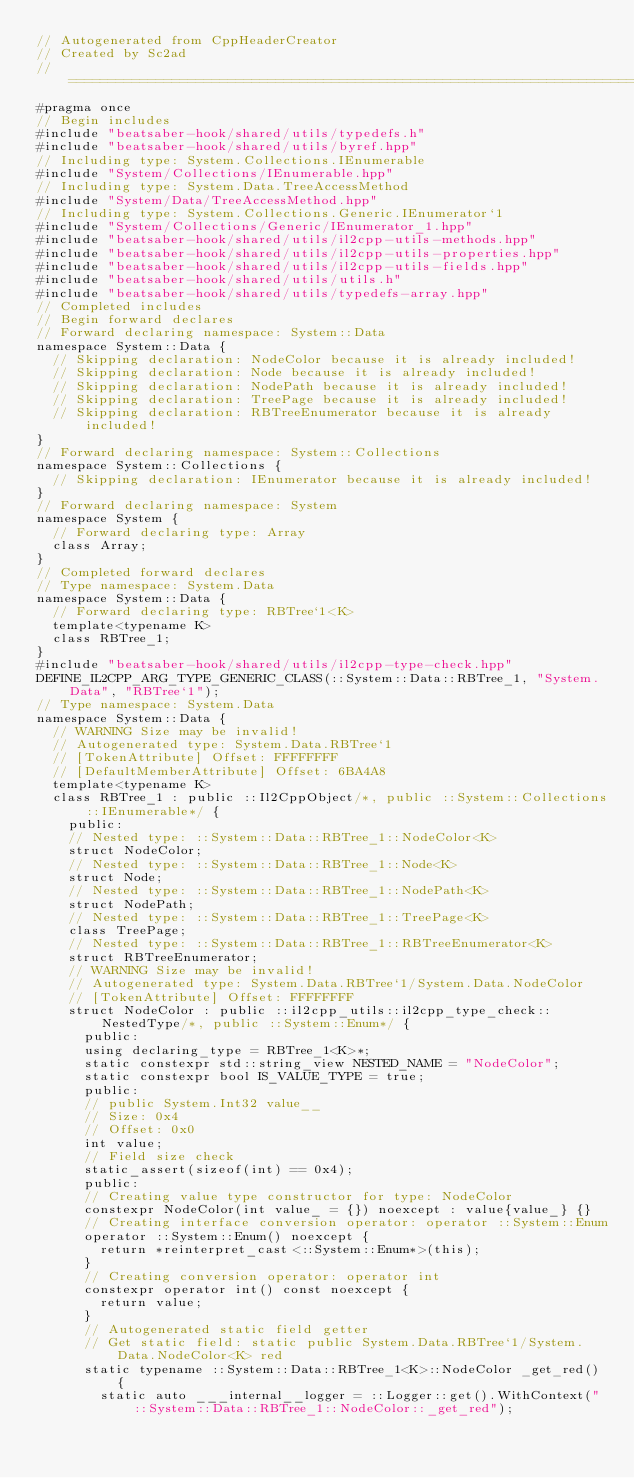Convert code to text. <code><loc_0><loc_0><loc_500><loc_500><_C++_>// Autogenerated from CppHeaderCreator
// Created by Sc2ad
// =========================================================================
#pragma once
// Begin includes
#include "beatsaber-hook/shared/utils/typedefs.h"
#include "beatsaber-hook/shared/utils/byref.hpp"
// Including type: System.Collections.IEnumerable
#include "System/Collections/IEnumerable.hpp"
// Including type: System.Data.TreeAccessMethod
#include "System/Data/TreeAccessMethod.hpp"
// Including type: System.Collections.Generic.IEnumerator`1
#include "System/Collections/Generic/IEnumerator_1.hpp"
#include "beatsaber-hook/shared/utils/il2cpp-utils-methods.hpp"
#include "beatsaber-hook/shared/utils/il2cpp-utils-properties.hpp"
#include "beatsaber-hook/shared/utils/il2cpp-utils-fields.hpp"
#include "beatsaber-hook/shared/utils/utils.h"
#include "beatsaber-hook/shared/utils/typedefs-array.hpp"
// Completed includes
// Begin forward declares
// Forward declaring namespace: System::Data
namespace System::Data {
  // Skipping declaration: NodeColor because it is already included!
  // Skipping declaration: Node because it is already included!
  // Skipping declaration: NodePath because it is already included!
  // Skipping declaration: TreePage because it is already included!
  // Skipping declaration: RBTreeEnumerator because it is already included!
}
// Forward declaring namespace: System::Collections
namespace System::Collections {
  // Skipping declaration: IEnumerator because it is already included!
}
// Forward declaring namespace: System
namespace System {
  // Forward declaring type: Array
  class Array;
}
// Completed forward declares
// Type namespace: System.Data
namespace System::Data {
  // Forward declaring type: RBTree`1<K>
  template<typename K>
  class RBTree_1;
}
#include "beatsaber-hook/shared/utils/il2cpp-type-check.hpp"
DEFINE_IL2CPP_ARG_TYPE_GENERIC_CLASS(::System::Data::RBTree_1, "System.Data", "RBTree`1");
// Type namespace: System.Data
namespace System::Data {
  // WARNING Size may be invalid!
  // Autogenerated type: System.Data.RBTree`1
  // [TokenAttribute] Offset: FFFFFFFF
  // [DefaultMemberAttribute] Offset: 6BA4A8
  template<typename K>
  class RBTree_1 : public ::Il2CppObject/*, public ::System::Collections::IEnumerable*/ {
    public:
    // Nested type: ::System::Data::RBTree_1::NodeColor<K>
    struct NodeColor;
    // Nested type: ::System::Data::RBTree_1::Node<K>
    struct Node;
    // Nested type: ::System::Data::RBTree_1::NodePath<K>
    struct NodePath;
    // Nested type: ::System::Data::RBTree_1::TreePage<K>
    class TreePage;
    // Nested type: ::System::Data::RBTree_1::RBTreeEnumerator<K>
    struct RBTreeEnumerator;
    // WARNING Size may be invalid!
    // Autogenerated type: System.Data.RBTree`1/System.Data.NodeColor
    // [TokenAttribute] Offset: FFFFFFFF
    struct NodeColor : public ::il2cpp_utils::il2cpp_type_check::NestedType/*, public ::System::Enum*/ {
      public:
      using declaring_type = RBTree_1<K>*;
      static constexpr std::string_view NESTED_NAME = "NodeColor";
      static constexpr bool IS_VALUE_TYPE = true;
      public:
      // public System.Int32 value__
      // Size: 0x4
      // Offset: 0x0
      int value;
      // Field size check
      static_assert(sizeof(int) == 0x4);
      public:
      // Creating value type constructor for type: NodeColor
      constexpr NodeColor(int value_ = {}) noexcept : value{value_} {}
      // Creating interface conversion operator: operator ::System::Enum
      operator ::System::Enum() noexcept {
        return *reinterpret_cast<::System::Enum*>(this);
      }
      // Creating conversion operator: operator int
      constexpr operator int() const noexcept {
        return value;
      }
      // Autogenerated static field getter
      // Get static field: static public System.Data.RBTree`1/System.Data.NodeColor<K> red
      static typename ::System::Data::RBTree_1<K>::NodeColor _get_red() {
        static auto ___internal__logger = ::Logger::get().WithContext("::System::Data::RBTree_1::NodeColor::_get_red");</code> 